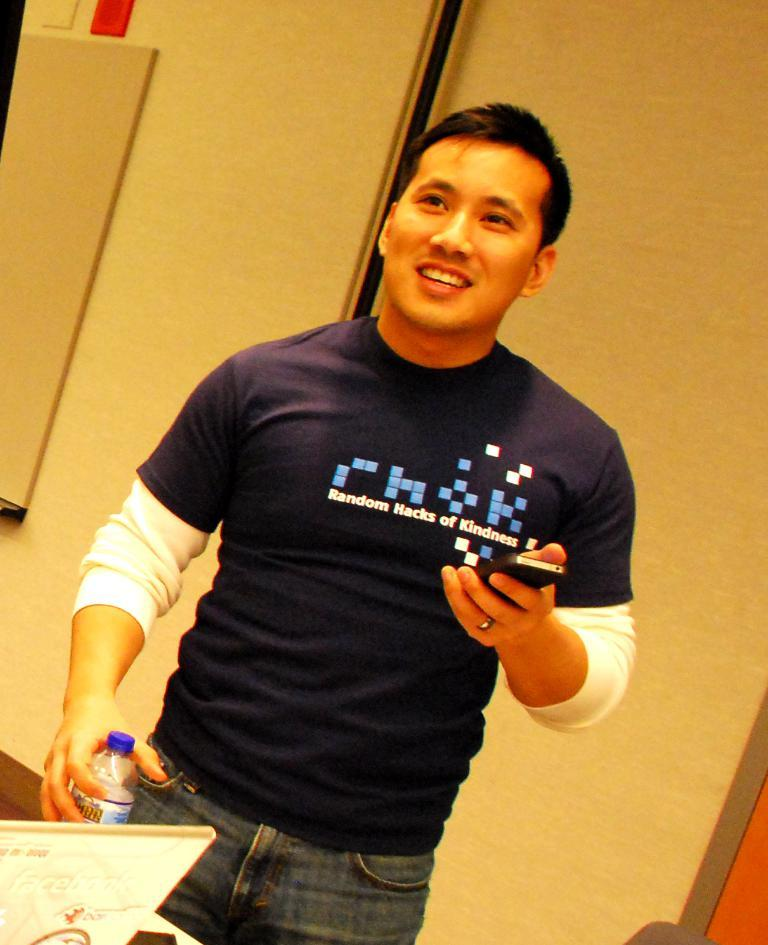What is the man in the image doing? The man is standing in the image. What object is the man holding in his hand? The man is holding a mobile in his hand. What can be seen in the background of the image? There is a mirror visible in the image. What electronic device is present in the image? There is a laptop in the image. What is on the table in the image? There is a water bottle on the table in the image. How many lizards are crawling on the man's arm in the image? There are no lizards present in the image. What type of bridge can be seen in the background of the image? There is no bridge visible in the image; it features a mirror in the background. 